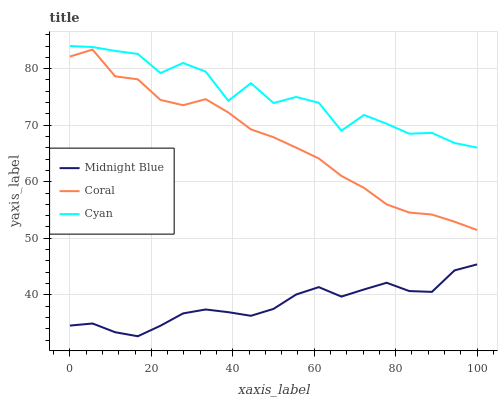Does Midnight Blue have the minimum area under the curve?
Answer yes or no. Yes. Does Cyan have the maximum area under the curve?
Answer yes or no. Yes. Does Coral have the minimum area under the curve?
Answer yes or no. No. Does Coral have the maximum area under the curve?
Answer yes or no. No. Is Midnight Blue the smoothest?
Answer yes or no. Yes. Is Cyan the roughest?
Answer yes or no. Yes. Is Coral the smoothest?
Answer yes or no. No. Is Coral the roughest?
Answer yes or no. No. Does Coral have the lowest value?
Answer yes or no. No. Does Cyan have the highest value?
Answer yes or no. Yes. Does Coral have the highest value?
Answer yes or no. No. Is Midnight Blue less than Coral?
Answer yes or no. Yes. Is Cyan greater than Midnight Blue?
Answer yes or no. Yes. Does Midnight Blue intersect Coral?
Answer yes or no. No. 